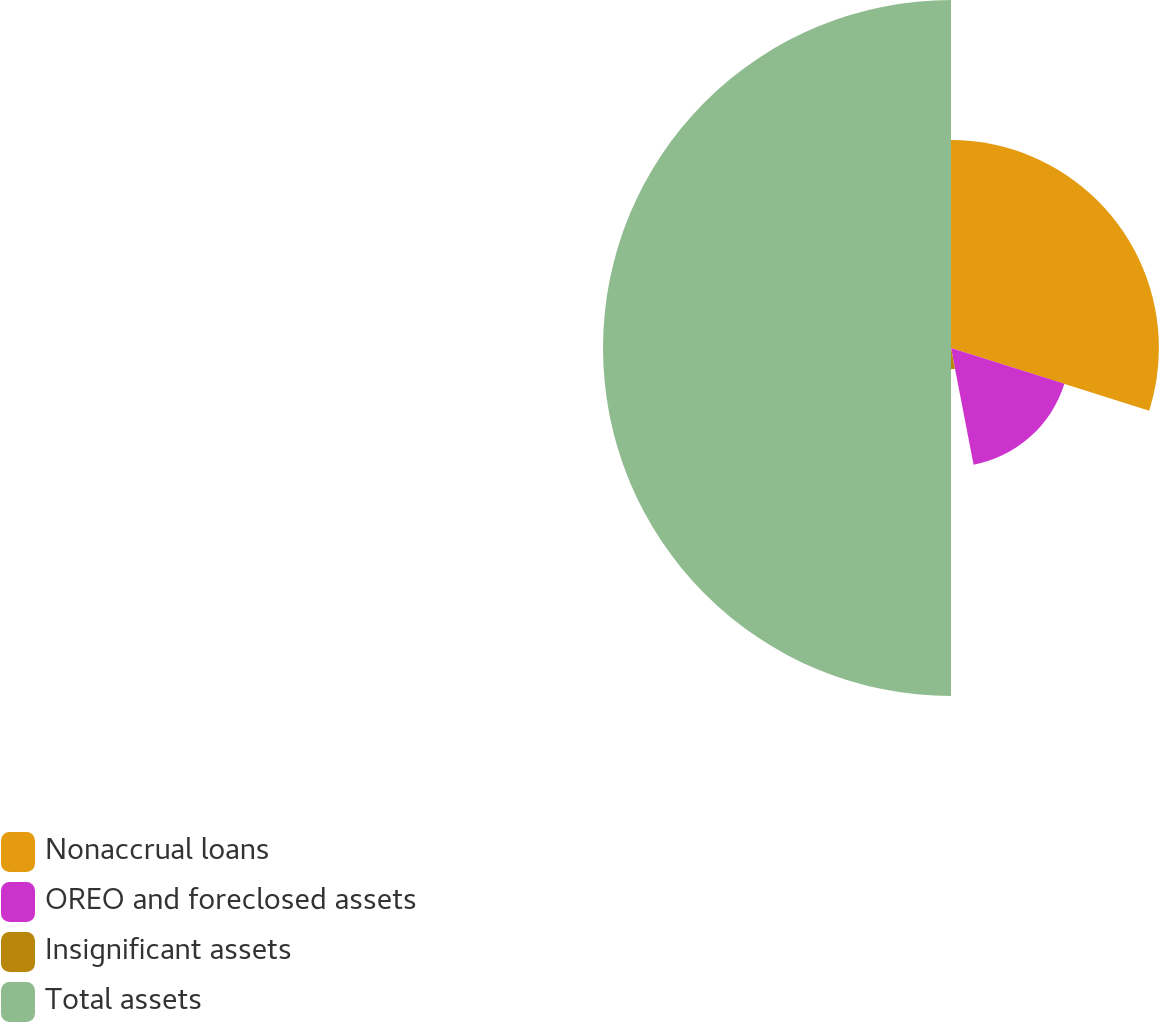Convert chart to OTSL. <chart><loc_0><loc_0><loc_500><loc_500><pie_chart><fcel>Nonaccrual loans<fcel>OREO and foreclosed assets<fcel>Insignificant assets<fcel>Total assets<nl><fcel>29.87%<fcel>17.09%<fcel>3.04%<fcel>50.0%<nl></chart> 